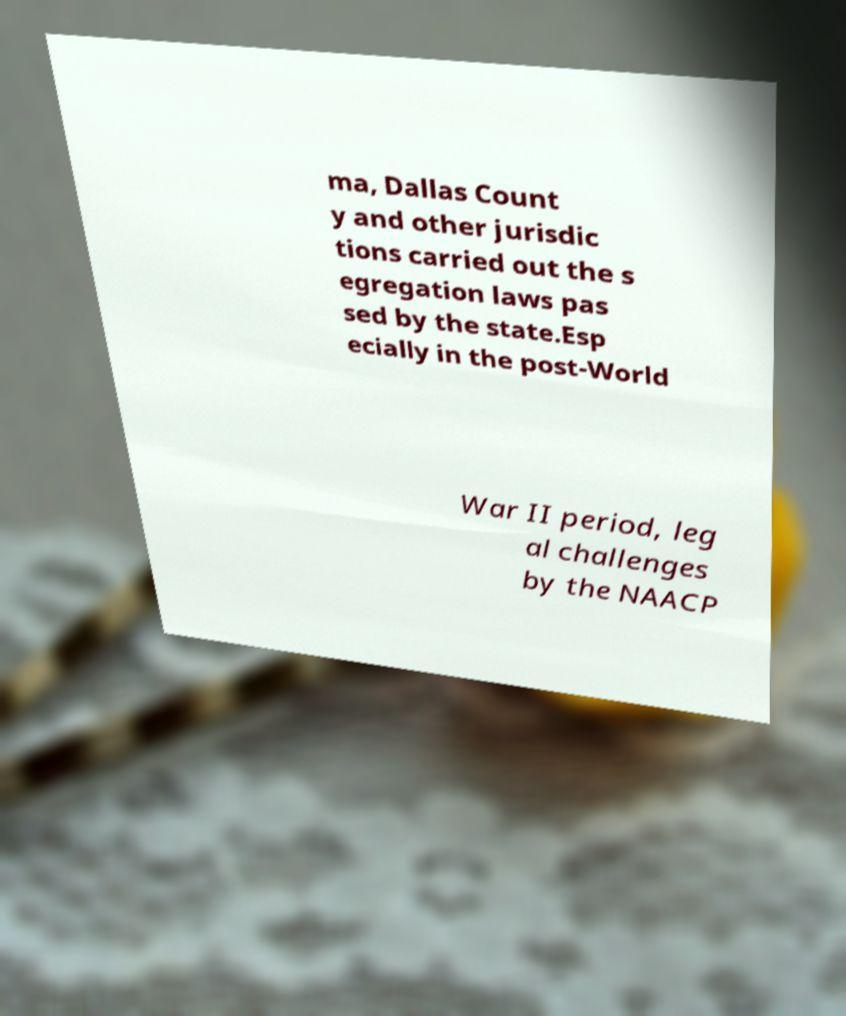For documentation purposes, I need the text within this image transcribed. Could you provide that? ma, Dallas Count y and other jurisdic tions carried out the s egregation laws pas sed by the state.Esp ecially in the post-World War II period, leg al challenges by the NAACP 